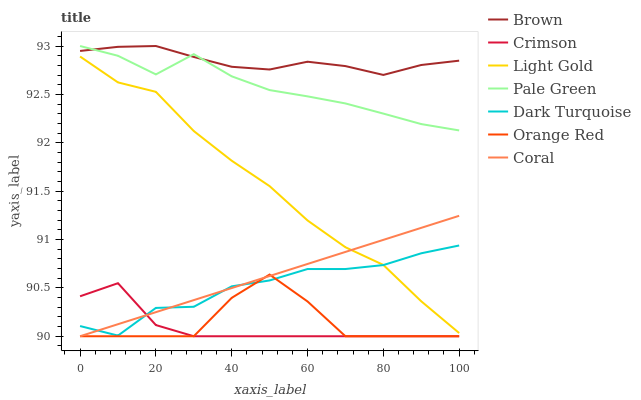Does Crimson have the minimum area under the curve?
Answer yes or no. Yes. Does Brown have the maximum area under the curve?
Answer yes or no. Yes. Does Dark Turquoise have the minimum area under the curve?
Answer yes or no. No. Does Dark Turquoise have the maximum area under the curve?
Answer yes or no. No. Is Coral the smoothest?
Answer yes or no. Yes. Is Orange Red the roughest?
Answer yes or no. Yes. Is Dark Turquoise the smoothest?
Answer yes or no. No. Is Dark Turquoise the roughest?
Answer yes or no. No. Does Coral have the lowest value?
Answer yes or no. Yes. Does Dark Turquoise have the lowest value?
Answer yes or no. No. Does Pale Green have the highest value?
Answer yes or no. Yes. Does Dark Turquoise have the highest value?
Answer yes or no. No. Is Orange Red less than Brown?
Answer yes or no. Yes. Is Brown greater than Orange Red?
Answer yes or no. Yes. Does Orange Red intersect Dark Turquoise?
Answer yes or no. Yes. Is Orange Red less than Dark Turquoise?
Answer yes or no. No. Is Orange Red greater than Dark Turquoise?
Answer yes or no. No. Does Orange Red intersect Brown?
Answer yes or no. No. 